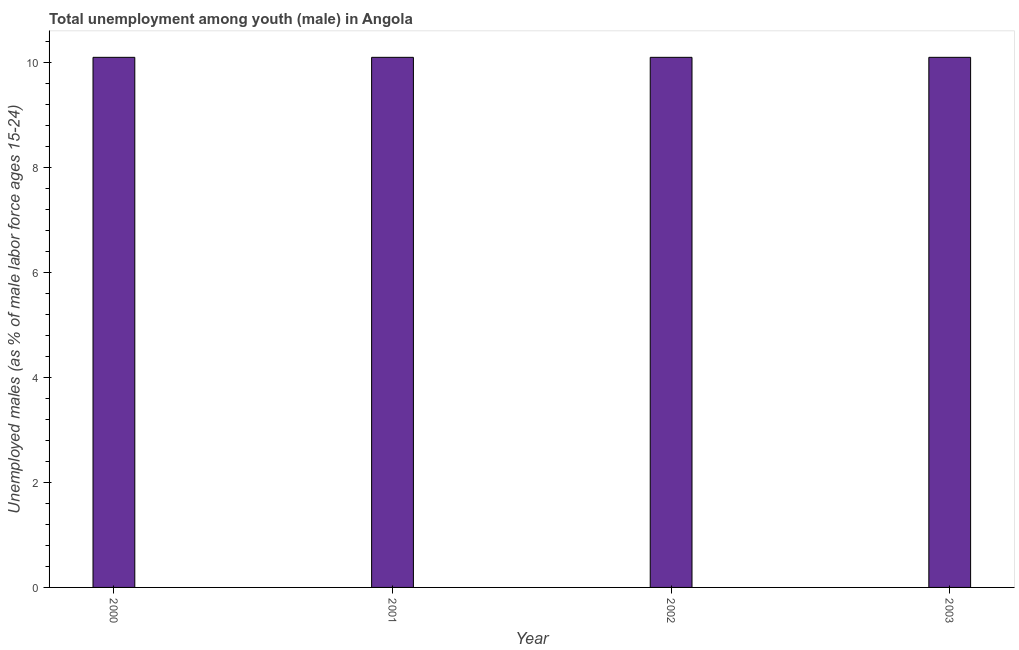Does the graph contain any zero values?
Provide a short and direct response. No. What is the title of the graph?
Keep it short and to the point. Total unemployment among youth (male) in Angola. What is the label or title of the X-axis?
Offer a very short reply. Year. What is the label or title of the Y-axis?
Provide a short and direct response. Unemployed males (as % of male labor force ages 15-24). What is the unemployed male youth population in 2000?
Keep it short and to the point. 10.1. Across all years, what is the maximum unemployed male youth population?
Provide a succinct answer. 10.1. Across all years, what is the minimum unemployed male youth population?
Your response must be concise. 10.1. In which year was the unemployed male youth population minimum?
Make the answer very short. 2000. What is the sum of the unemployed male youth population?
Give a very brief answer. 40.4. What is the difference between the unemployed male youth population in 2000 and 2003?
Your answer should be very brief. 0. What is the average unemployed male youth population per year?
Your answer should be very brief. 10.1. What is the median unemployed male youth population?
Provide a short and direct response. 10.1. In how many years, is the unemployed male youth population greater than 4 %?
Make the answer very short. 4. Do a majority of the years between 2002 and 2003 (inclusive) have unemployed male youth population greater than 9.6 %?
Make the answer very short. Yes. Is the difference between the unemployed male youth population in 2000 and 2002 greater than the difference between any two years?
Offer a very short reply. Yes. What is the difference between the highest and the second highest unemployed male youth population?
Your response must be concise. 0. In how many years, is the unemployed male youth population greater than the average unemployed male youth population taken over all years?
Your answer should be very brief. 0. How many bars are there?
Your answer should be compact. 4. How many years are there in the graph?
Your answer should be compact. 4. What is the difference between two consecutive major ticks on the Y-axis?
Keep it short and to the point. 2. What is the Unemployed males (as % of male labor force ages 15-24) in 2000?
Your answer should be compact. 10.1. What is the Unemployed males (as % of male labor force ages 15-24) in 2001?
Offer a terse response. 10.1. What is the Unemployed males (as % of male labor force ages 15-24) of 2002?
Give a very brief answer. 10.1. What is the Unemployed males (as % of male labor force ages 15-24) of 2003?
Make the answer very short. 10.1. What is the difference between the Unemployed males (as % of male labor force ages 15-24) in 2000 and 2001?
Ensure brevity in your answer.  0. What is the difference between the Unemployed males (as % of male labor force ages 15-24) in 2001 and 2002?
Your answer should be compact. 0. What is the ratio of the Unemployed males (as % of male labor force ages 15-24) in 2000 to that in 2001?
Keep it short and to the point. 1. What is the ratio of the Unemployed males (as % of male labor force ages 15-24) in 2001 to that in 2002?
Offer a very short reply. 1. What is the ratio of the Unemployed males (as % of male labor force ages 15-24) in 2002 to that in 2003?
Your response must be concise. 1. 